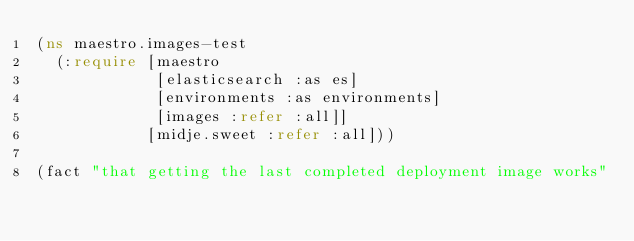Convert code to text. <code><loc_0><loc_0><loc_500><loc_500><_Clojure_>(ns maestro.images-test
  (:require [maestro
             [elasticsearch :as es]
             [environments :as environments]
             [images :refer :all]]
            [midje.sweet :refer :all]))

(fact "that getting the last completed deployment image works"</code> 